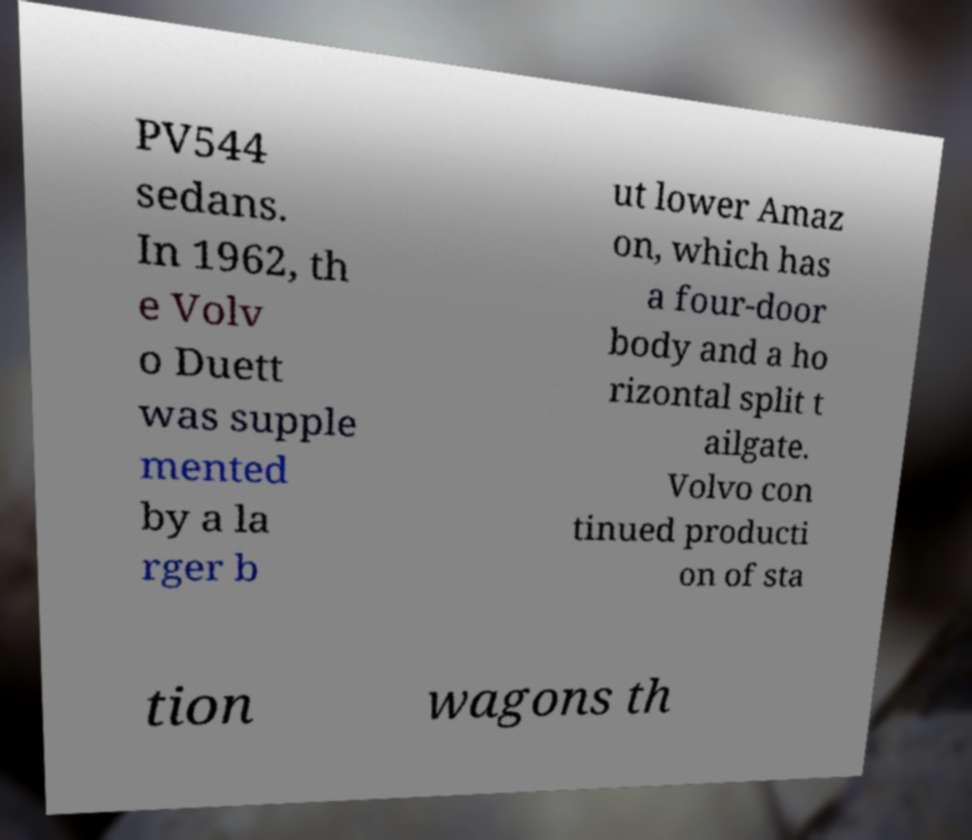Please read and relay the text visible in this image. What does it say? PV544 sedans. In 1962, th e Volv o Duett was supple mented by a la rger b ut lower Amaz on, which has a four-door body and a ho rizontal split t ailgate. Volvo con tinued producti on of sta tion wagons th 